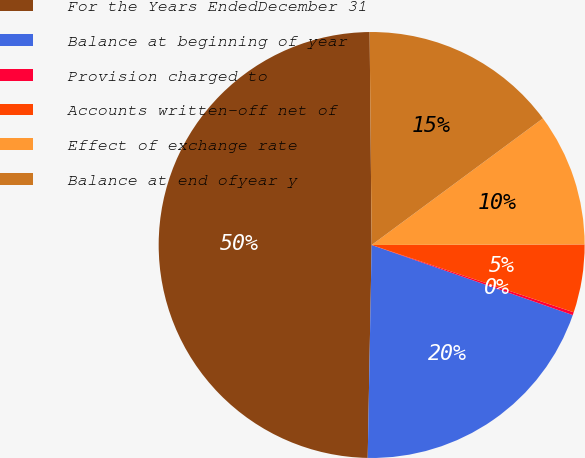Convert chart to OTSL. <chart><loc_0><loc_0><loc_500><loc_500><pie_chart><fcel>For the Years EndedDecember 31<fcel>Balance at beginning of year<fcel>Provision charged to<fcel>Accounts written-off net of<fcel>Effect of exchange rate<fcel>Balance at end ofyear y<nl><fcel>49.56%<fcel>19.96%<fcel>0.22%<fcel>5.16%<fcel>10.09%<fcel>15.02%<nl></chart> 